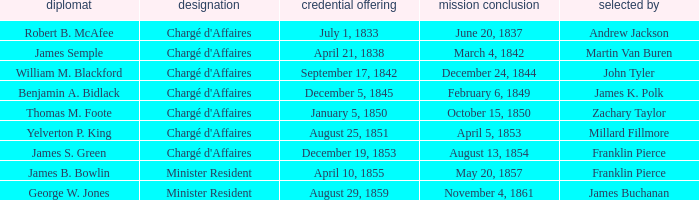What Title has a Termination of Mission for August 13, 1854? Chargé d'Affaires. 